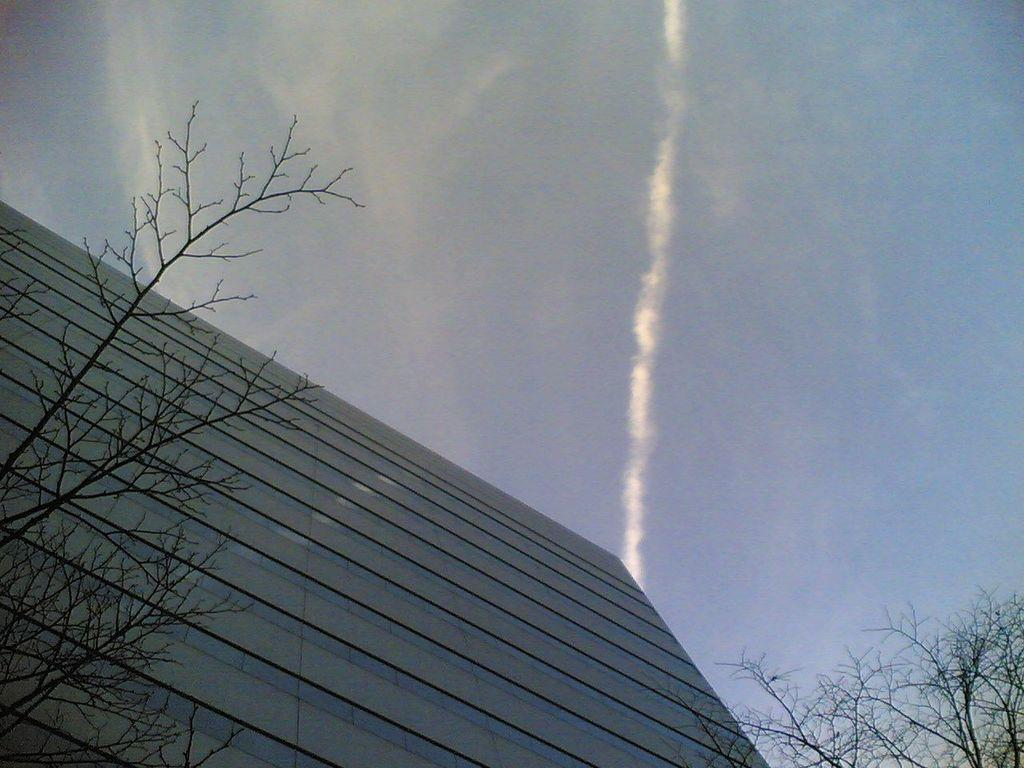What is the perspective of the image? The image is taken from the bottom of a building. What is the main subject in the middle of the image? There is a building in the middle of the image. What type of vegetation is on either side of the building? There are trees on either side of the building. What is visible at the top of the image? The sky is visible at the top of the image. What type of stick can be seen in the image? There is no stick present in the image. What kind of wine is being served in the image? There is no wine present in the image. 